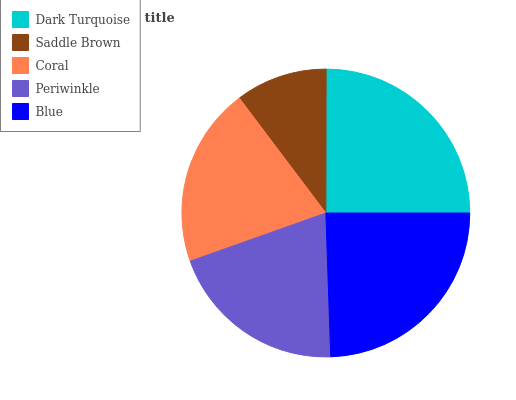Is Saddle Brown the minimum?
Answer yes or no. Yes. Is Dark Turquoise the maximum?
Answer yes or no. Yes. Is Coral the minimum?
Answer yes or no. No. Is Coral the maximum?
Answer yes or no. No. Is Coral greater than Saddle Brown?
Answer yes or no. Yes. Is Saddle Brown less than Coral?
Answer yes or no. Yes. Is Saddle Brown greater than Coral?
Answer yes or no. No. Is Coral less than Saddle Brown?
Answer yes or no. No. Is Coral the high median?
Answer yes or no. Yes. Is Coral the low median?
Answer yes or no. Yes. Is Saddle Brown the high median?
Answer yes or no. No. Is Blue the low median?
Answer yes or no. No. 